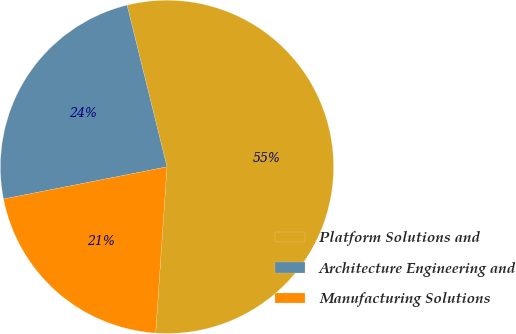<chart> <loc_0><loc_0><loc_500><loc_500><pie_chart><fcel>Platform Solutions and<fcel>Architecture Engineering and<fcel>Manufacturing Solutions<nl><fcel>54.93%<fcel>24.24%<fcel>20.83%<nl></chart> 